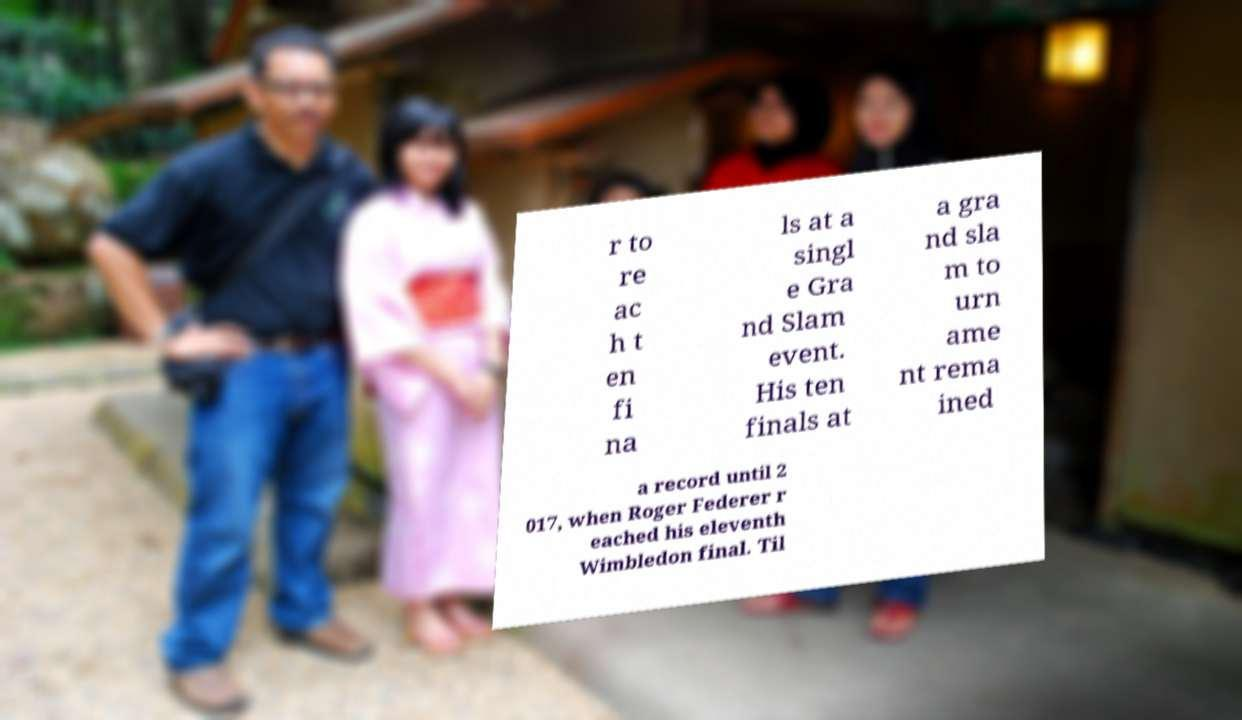There's text embedded in this image that I need extracted. Can you transcribe it verbatim? r to re ac h t en fi na ls at a singl e Gra nd Slam event. His ten finals at a gra nd sla m to urn ame nt rema ined a record until 2 017, when Roger Federer r eached his eleventh Wimbledon final. Til 